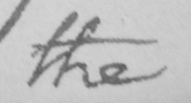Can you read and transcribe this handwriting? the 